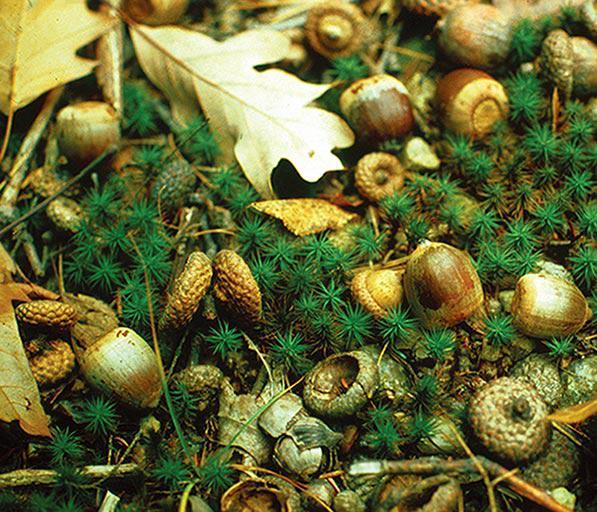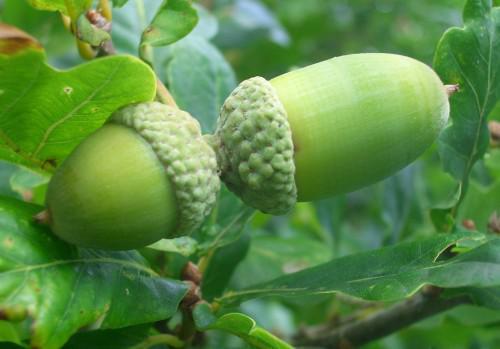The first image is the image on the left, the second image is the image on the right. Evaluate the accuracy of this statement regarding the images: "The right image features exactly two green-skinned acorns with their green caps back-to-back.". Is it true? Answer yes or no. Yes. The first image is the image on the left, the second image is the image on the right. Considering the images on both sides, is "There are two green acorns and green acorn tops still attach to each other" valid? Answer yes or no. Yes. 